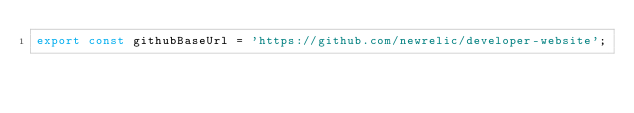<code> <loc_0><loc_0><loc_500><loc_500><_JavaScript_>export const githubBaseUrl = 'https://github.com/newrelic/developer-website';
</code> 